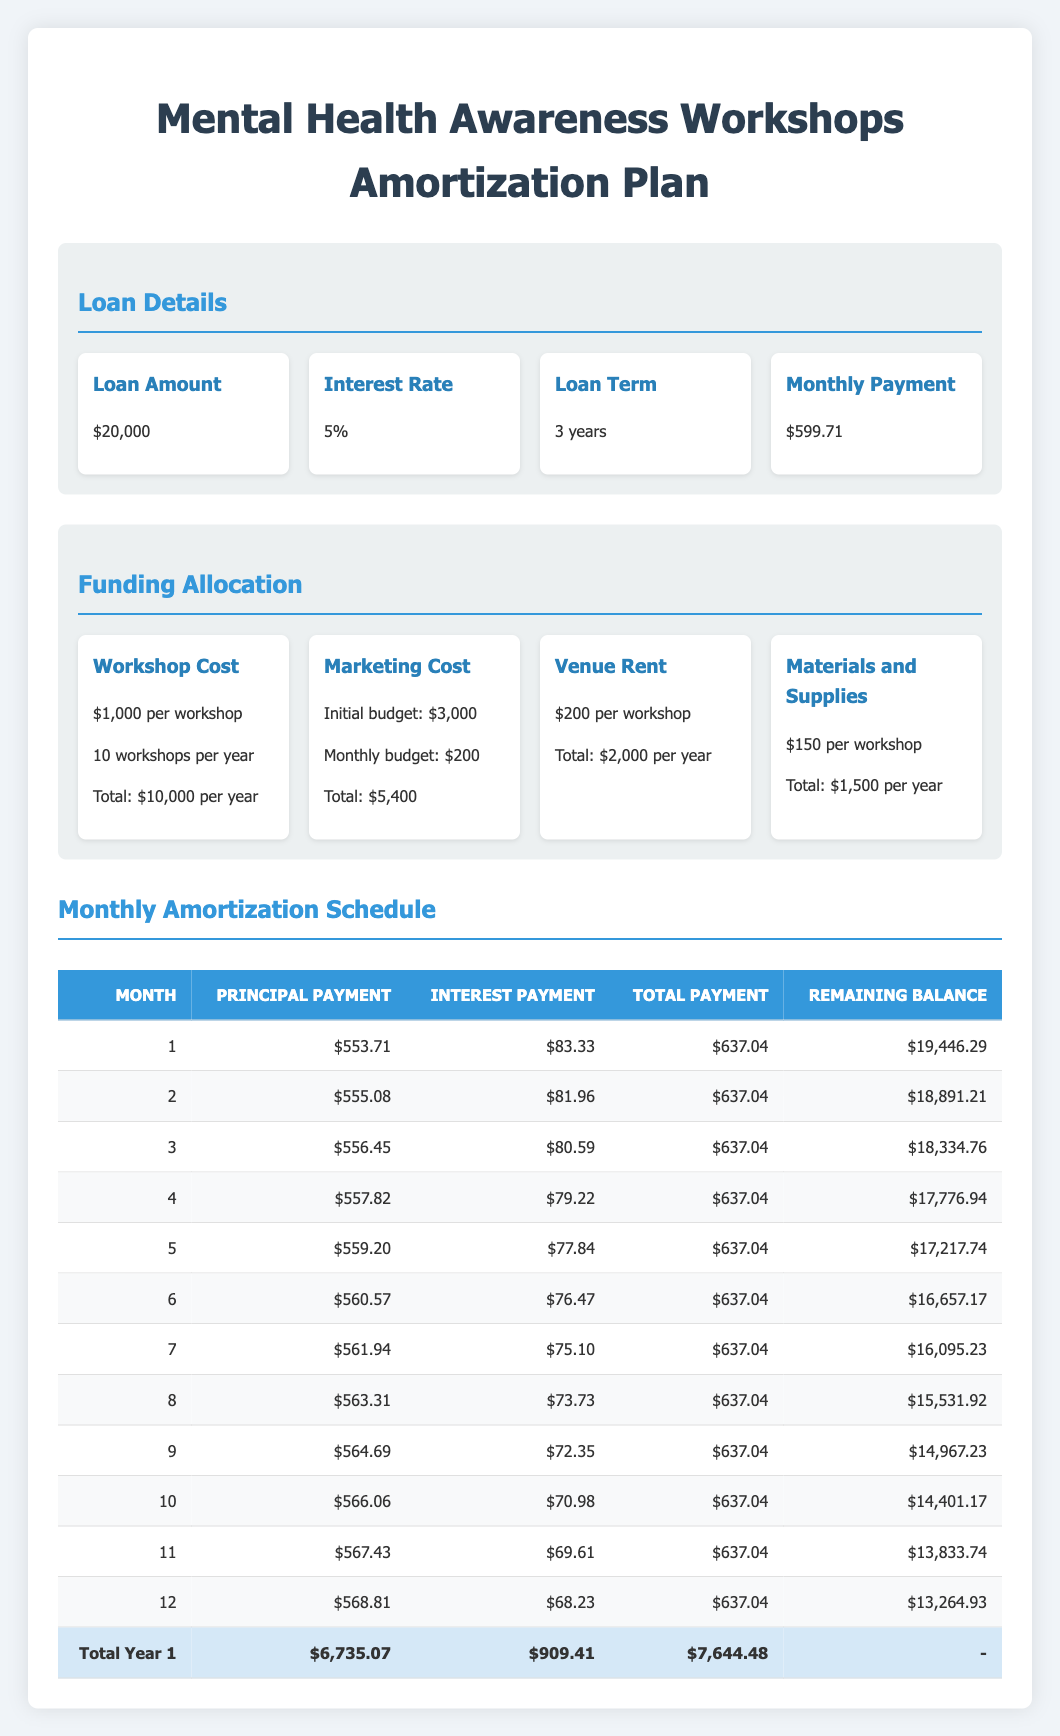What is the total monthly payment for the loan? The monthly payment is listed in the loan details section as $599.71.
Answer: $599.71 How much principal payment is made in the third month? From the amortization schedule, the principal payment in month 3 is $556.45.
Answer: $556.45 What is the remaining balance after the first month? According to the first row of the amortization schedule, the remaining balance after the first month is $19,446.29.
Answer: $19,446.29 What is the total principal payment for the first year? The total principal payment can be calculated by adding the principal payments from each of the 12 months, which sum up to $6,735.07 as shown in the total row at the end of the first year.
Answer: $6,735.07 Is the interest payment for month 11 greater than month 12? By comparing the interest payments in month 11 ($69.61) and month 12 ($68.23), we see that month 11 has a higher interest payment.
Answer: Yes What is the average remaining balance after the first six months? The remaining balances for the first six months are $19,446.29, $18,891.21, $18,334.76, $17,776.94, $17,217.74, and $16,657.17. The sum is $108,424.11, and dividing by 6 gives an average of $18,070.69.
Answer: $18,070.69 What was the total marketing cost allocated for one year? The marketing cost allocation includes an initial budget of $3,000 plus an ongoing monthly budget of $200 over 12 months (which totals $2,400). Adding these amounts gives $3,000 + $2,400 = $5,400.
Answer: $5,400 How much is spent on venue rent for all workshops in one year? The venue rent is $200 per workshop, and since 10 workshops are conducted in a year, the total is 10 * $200 = $2,000.
Answer: $2,000 In the fourth month, what were the total payments made? The total payment in any month can be found by adding the principal payment and interest payment. For month 4, the total is $557.82 (principal) + $79.22 (interest) = $637.04.
Answer: $637.04 